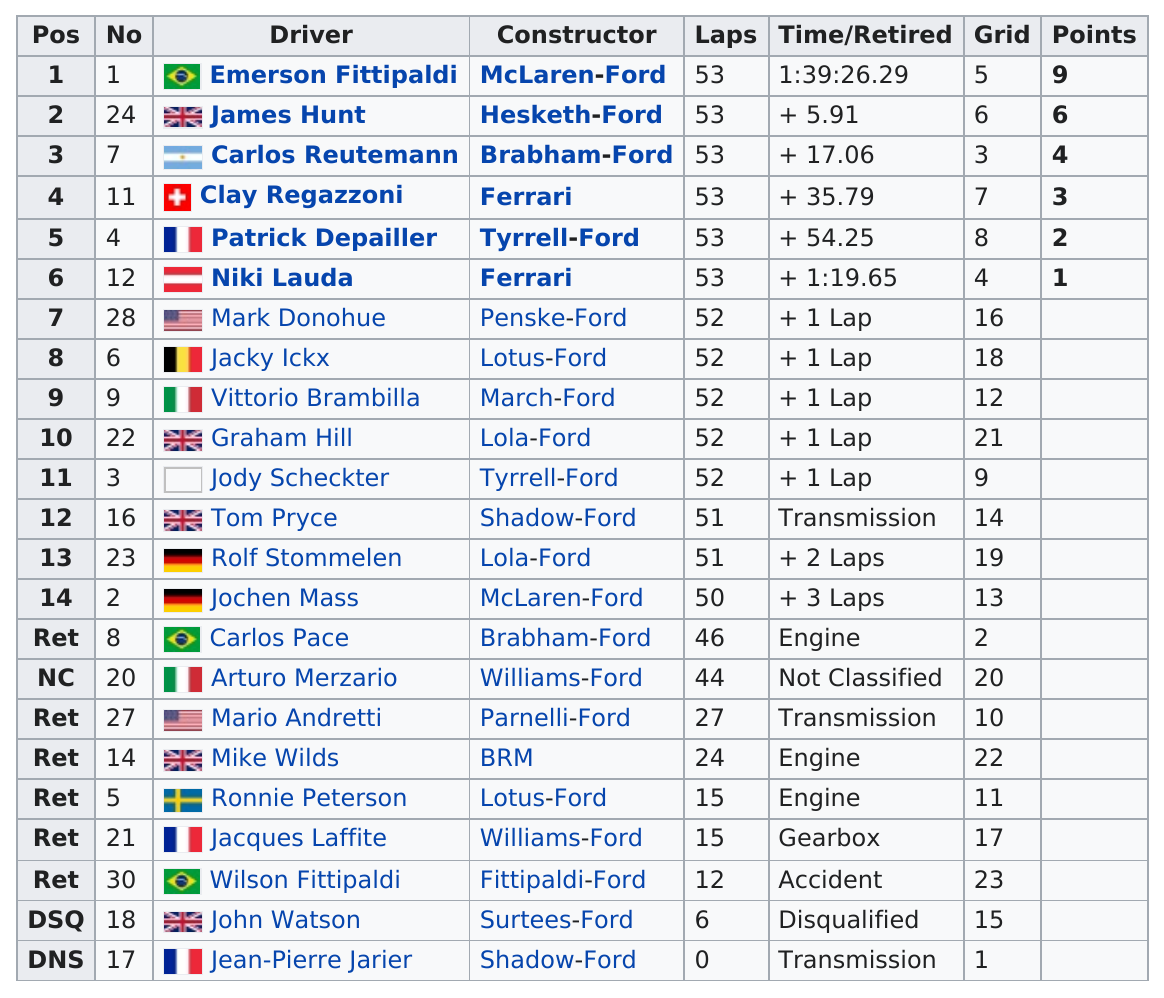Draw attention to some important aspects in this diagram. Six drivers finished with the most laps completed. Carlos completed fewer laps than Jochen in the race. Clay Regazzoni had the best experience driving a Ferrari. Emerson Fittipaldi received a total of 9 points. James Hunt is the only person from the UK in the top 3. 